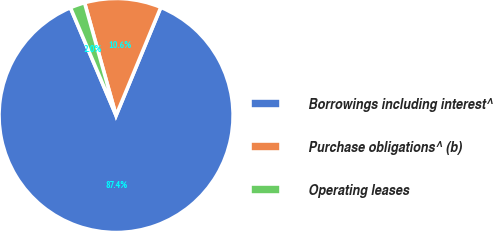<chart> <loc_0><loc_0><loc_500><loc_500><pie_chart><fcel>Borrowings including interest^<fcel>Purchase obligations^ (b)<fcel>Operating leases<nl><fcel>87.38%<fcel>10.58%<fcel>2.04%<nl></chart> 